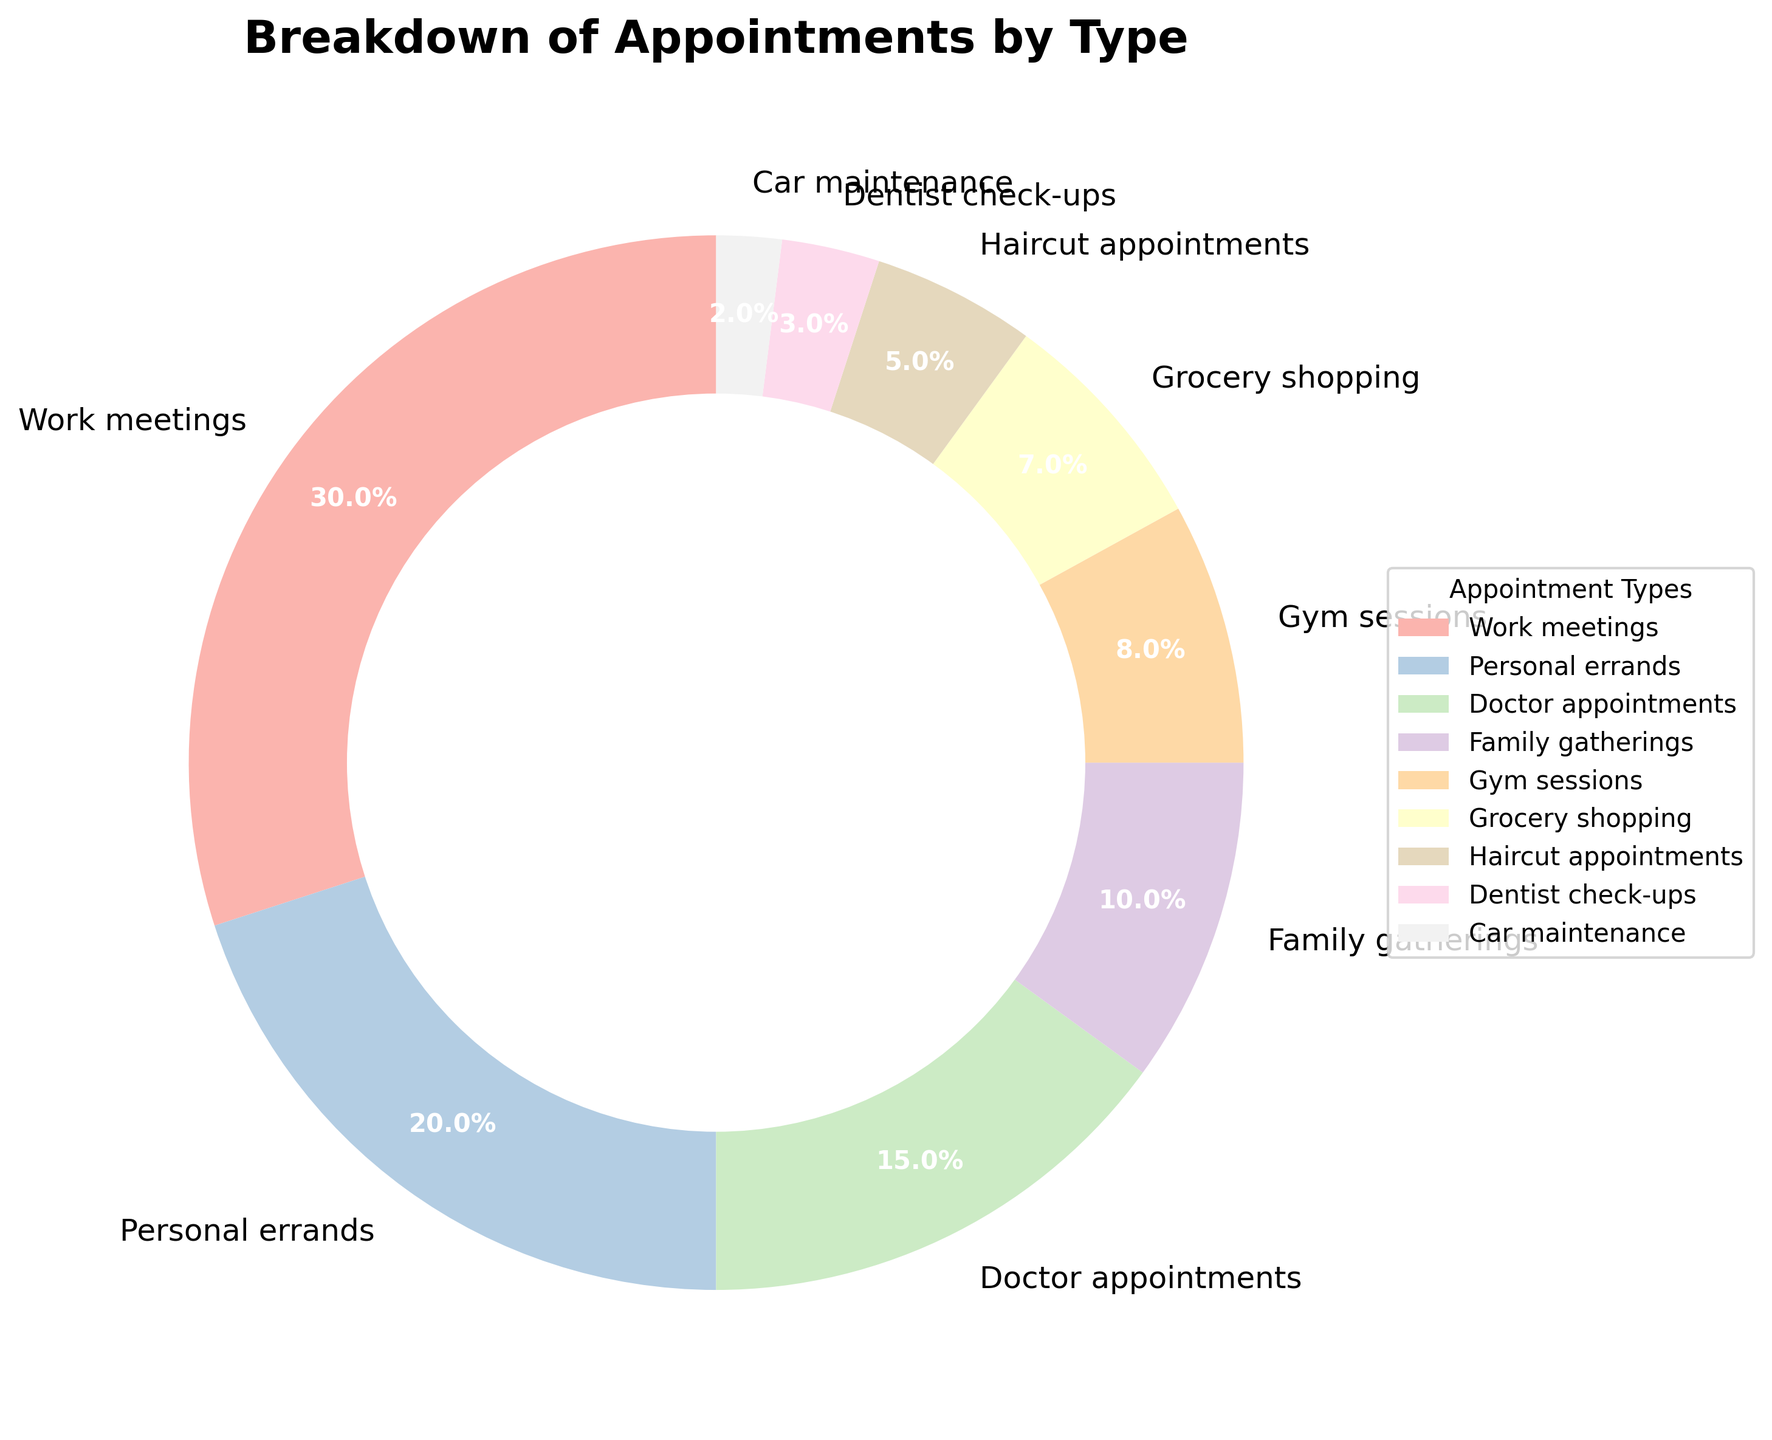Which type of appointment occupies the largest percentage? The figure shows that 'Work meetings' have the largest segment with 30%.
Answer: Work meetings Which two types of appointments make up a fifth of the total appointments when combined? The figure shows that 'Doctor appointments' (15%) and 'Family gatherings' (10%) add up to 15% + 10% = 25%, which is one-fourth. 'Personal errands' (20%) alone make up 20%. So, no combination makes up exactly a fifth (20%).
Answer: None What is the percentage difference between 'Personal errands' and 'Gym sessions'? The percentages are 20% for 'Personal errands' and 8% for 'Gym sessions'. The difference is 20% - 8% = 12%.
Answer: 12% How many types of appointments make up more than 10%? The figure shows 'Work meetings' (30%), 'Personal errands' (20%), and 'Doctor appointments' (15%), all of which are more than 10%.
Answer: 3 Compare the combined percentage of 'Grocery shopping' and 'Haircut appointments' to 'Doctor appointments'. Which is larger? 'Grocery shopping' is 7%, and 'Haircut appointments' are 5%, totaling 7% + 5% = 12%. 'Doctor appointments' are 15%, so 'Doctor appointments' are larger.
Answer: Doctor appointments What percentage of appointments are health-related (Doctor appointments and Dentist check-ups)? 'Doctor appointments' are 15%, and 'Dentist check-ups' are 3%. The combined percentage is 15% + 3% = 18%.
Answer: 18% Which type of appointment has the smallest percentage, and what is it? The figure shows that 'Car maintenance' has the smallest segment with 2%.
Answer: Car maintenance, 2% Is the percentage for 'Haircut appointments' greater than the percentage for 'Dentist check-ups'? The figure shows that 'Haircut appointments' are 5%, and 'Dentist check-ups' are 3%. Therefore, 5% is greater than 3%.
Answer: Yes What is the visual color representing 'Work meetings' in the pie chart? The segment for 'Work meetings' will be shown in a specific color on the pie chart — likely a pastel shade — such as light pink or light blue, but we should check the visual directly to identify the exact color.
Answer: Pastel color (like light pink or light blue) Which types of appointments together make up more than half of the total percentage? The largest segments are 'Work meetings' (30%) and 'Personal errands' (20%), adding up to 30% + 20% = 50%. Combined with any other type, the total will exceed half, e.g., adding 'Doctor appointments' (15%) to get 65%.
Answer: Work meetings, Personal errands, and Doctor appointments 